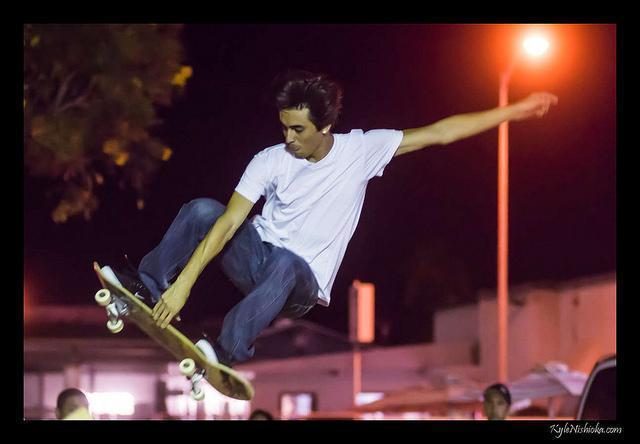How many sheep walking in a line in this picture?
Give a very brief answer. 0. 